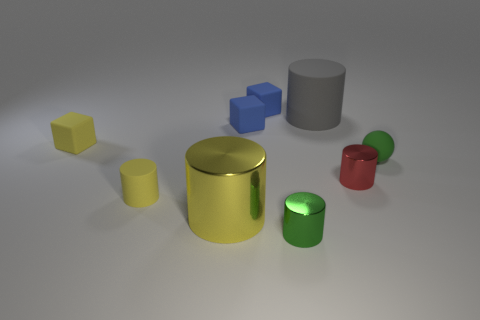Can you describe the lighting conditions in the image? The lighting in the image is soft and diffuse, creating gentle shadows beneath the cylinders. It appears to be coming from a source outside of the frame, possibly overhead, and gives the objects a three-dimensional appearance without causing any harsh or overly dramatic shadows. 